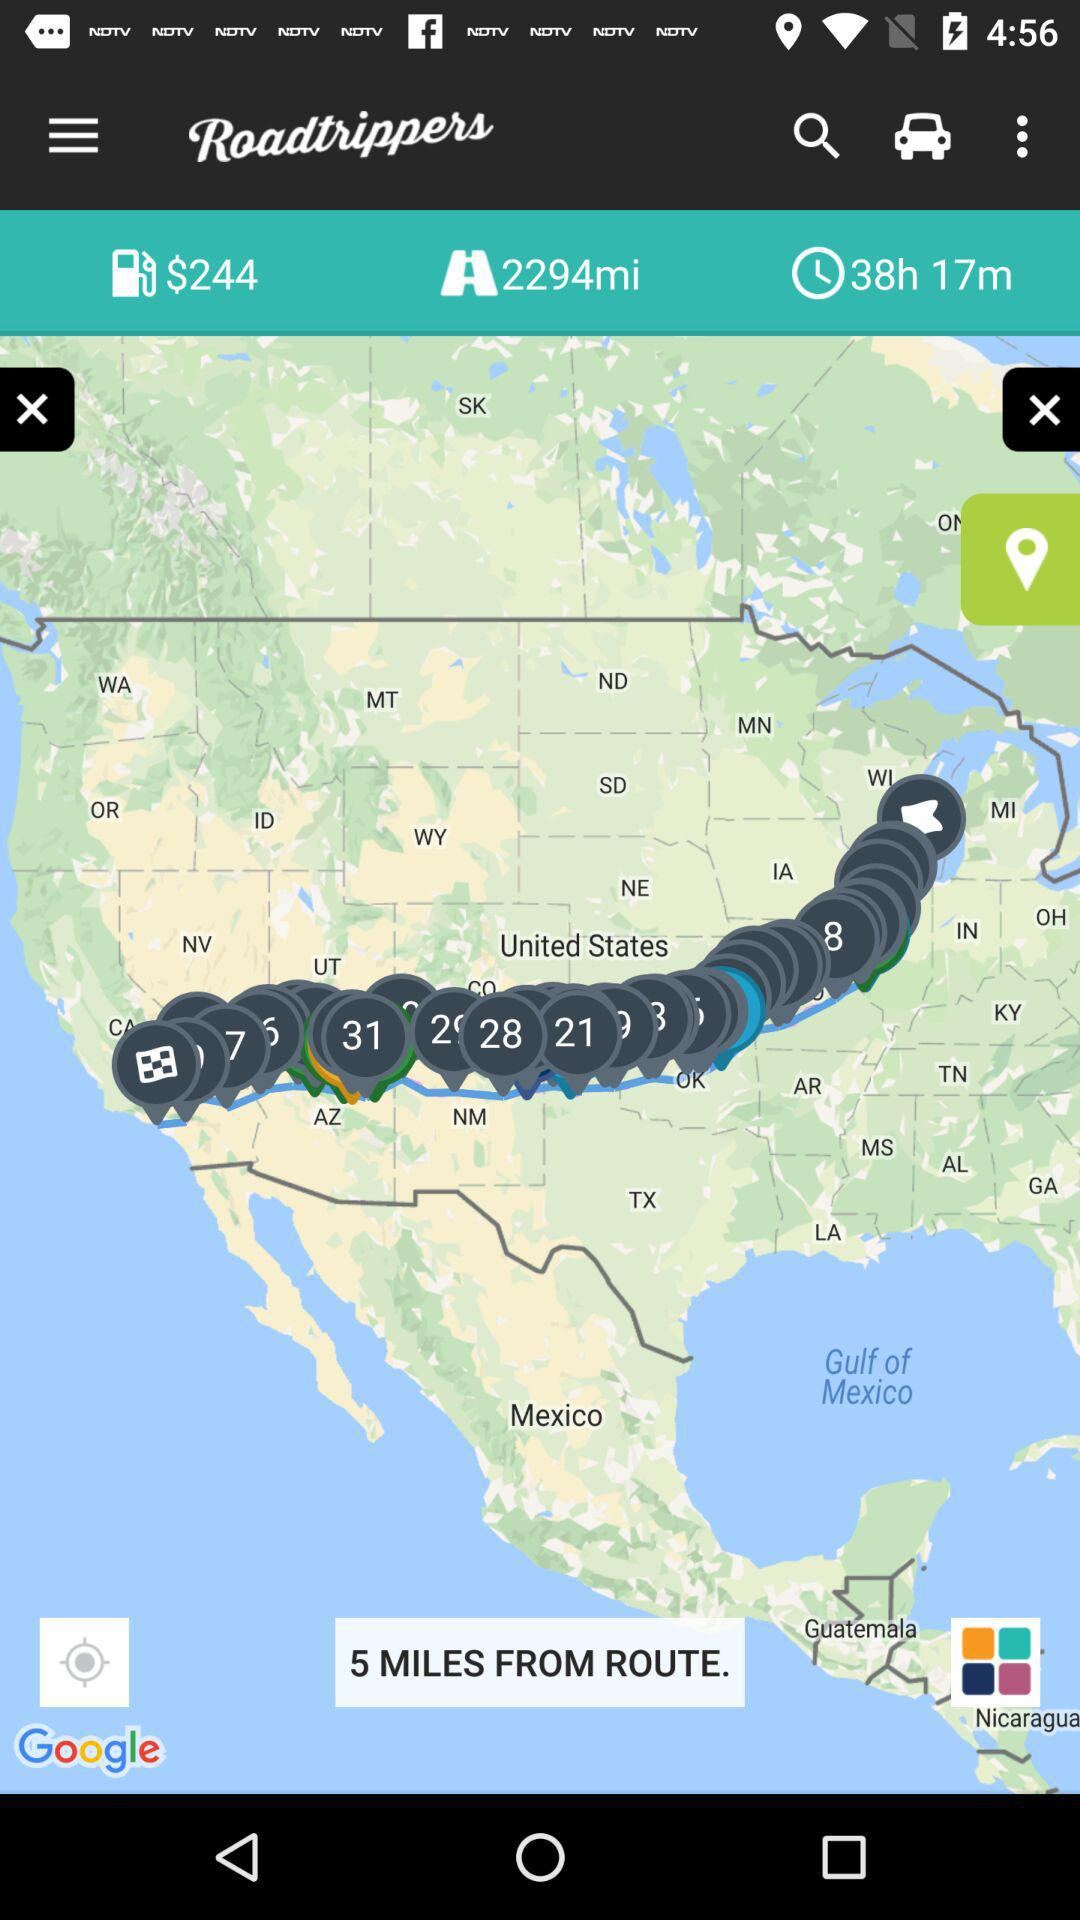How much time is remaining?
When the provided information is insufficient, respond with <no answer>. <no answer> 